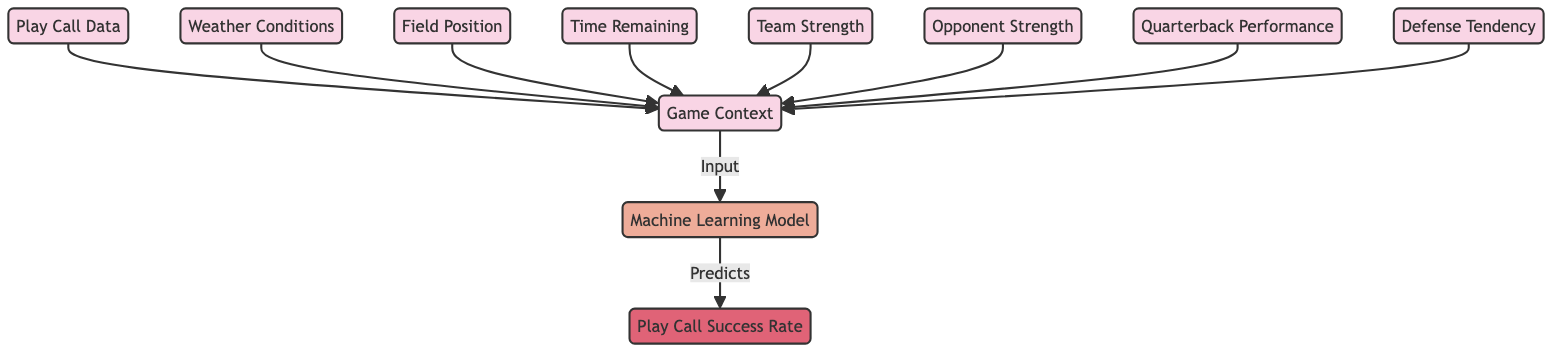What is the output node of the diagram? The output node in the diagram is labeled "Play Call Success Rate," which is the result predicted by the machine learning model.
Answer: Play Call Success Rate Which node provides input related to the player's performance? The node that provides input related to the player's performance is "Quarterback Performance," which evaluates how well the quarterback is playing.
Answer: Quarterback Performance How many context nodes are in the diagram? There are eight context nodes in the diagram: Game Context, Weather Conditions, Field Position, Time Remaining, Team Strength, Opponent Strength, Quarterback Performance, and Defense Tendency.
Answer: Eight What kind of model is included in the diagram? The model indicated in the diagram is a "Machine Learning Model," which utilizes various inputs to make predictions about play call success rates.
Answer: Machine Learning Model Which nodes directly connect to the machine learning model? The nodes that directly connect to the machine learning model are: Game Context, which integrates all other context nodes.
Answer: Game Context Which two context nodes deal specifically with team dynamics? The two context nodes that deal specifically with team dynamics are "Team Strength" and "Opponent Strength," which focus on the comparative performance of the involved teams.
Answer: Team Strength, Opponent Strength What is the relationship between "Game Context" and "Machine Learning Model"? "Game Context" is an input to the "Machine Learning Model," meaning the model uses this information to make its predictions.
Answer: Input How many direct inputs are there to the "Machine Learning Model"? There are nine direct inputs to the "Machine Learning Model," counting the "Game Context" as a consolidating node for eight other context nodes.
Answer: Nine What type of data does "Play Call Data" correlate with in the diagram? "Play Call Data" correlates with "Game Context," indicating that it provides relevant game information for analyzing the effectiveness of the play.
Answer: Game Context 